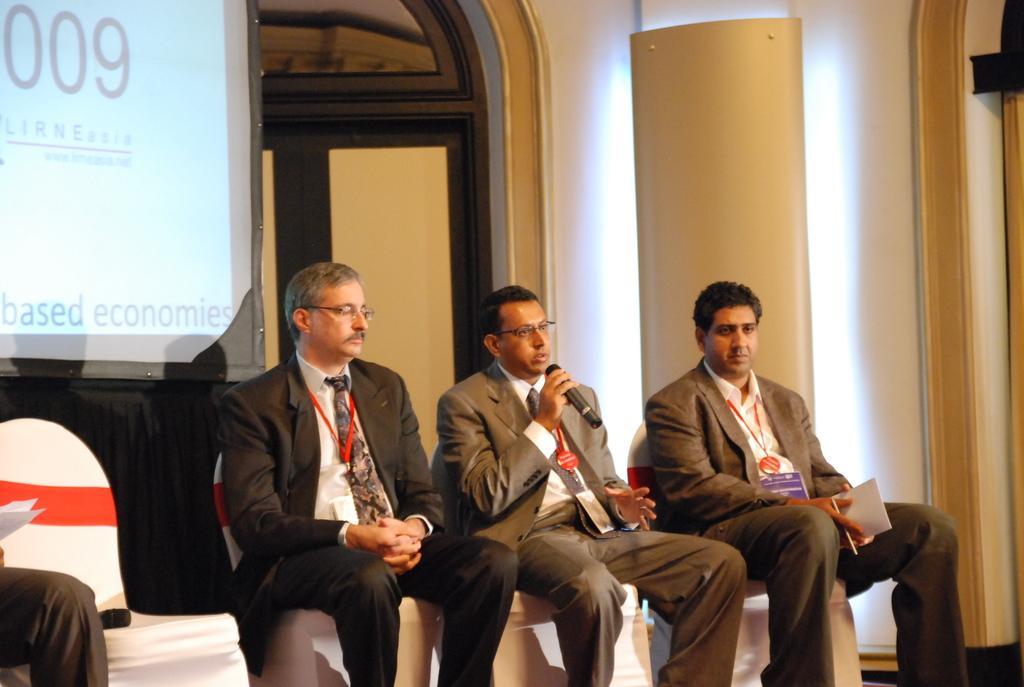In one or two sentences, can you explain what this image depicts? This picture might be clicked in a conference hall. Here, we see three people sitting on the chairs. The man in the middle of the picture wearing a grey blazer is holding a microphone in his hand and he is talking on the microphone. Beside him, we see a man who is holding a paper and pen in his hand. Behind them, we see a projector screen with some text displayed on it. Beside that, we see a door and beside the door, we see a white wall. 